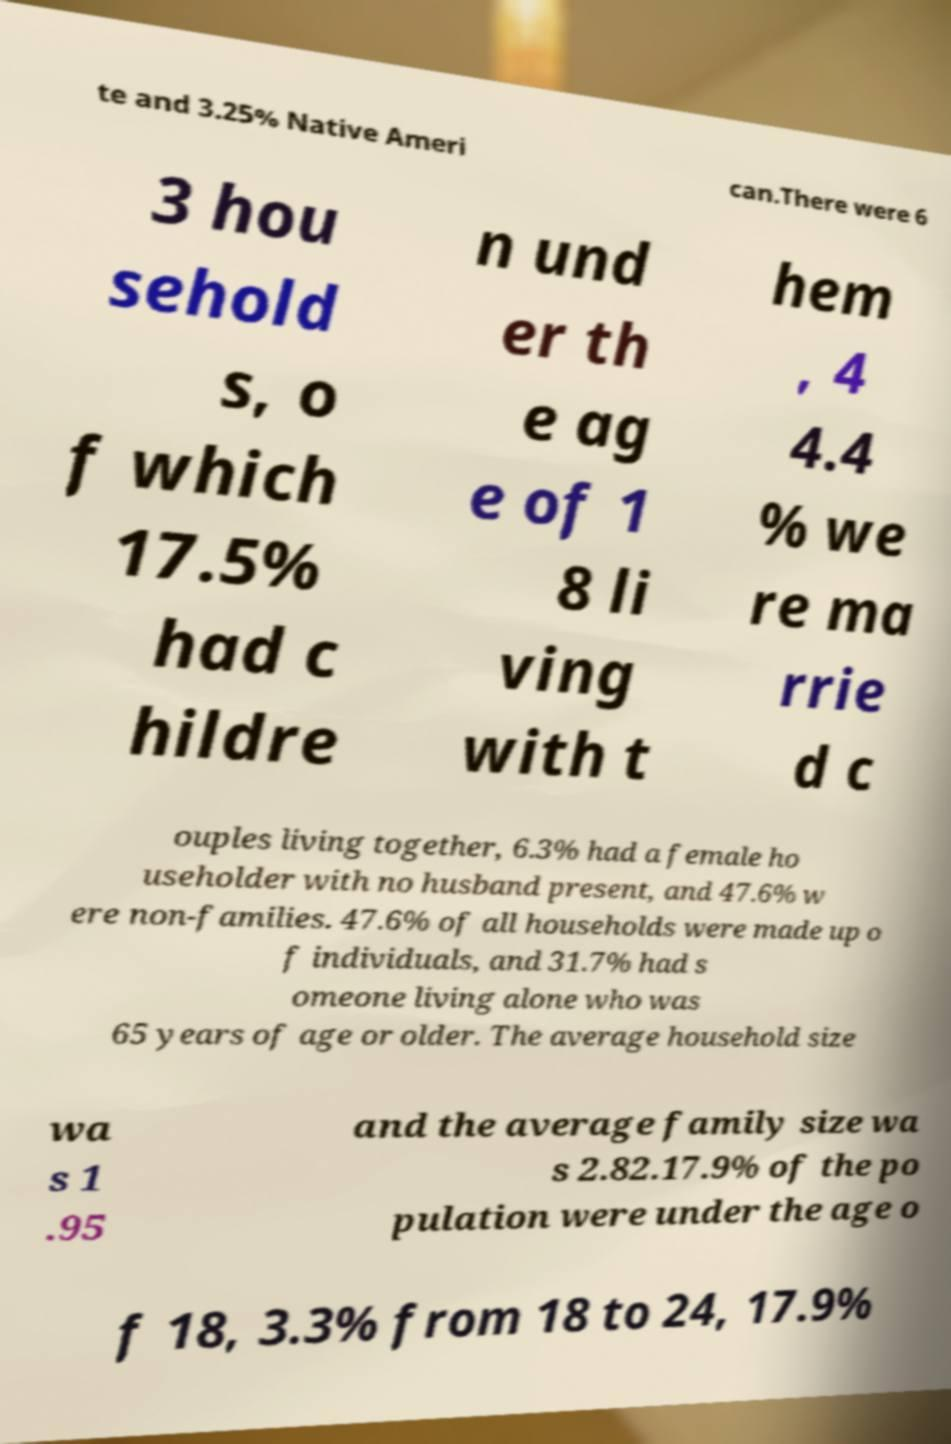Can you read and provide the text displayed in the image?This photo seems to have some interesting text. Can you extract and type it out for me? te and 3.25% Native Ameri can.There were 6 3 hou sehold s, o f which 17.5% had c hildre n und er th e ag e of 1 8 li ving with t hem , 4 4.4 % we re ma rrie d c ouples living together, 6.3% had a female ho useholder with no husband present, and 47.6% w ere non-families. 47.6% of all households were made up o f individuals, and 31.7% had s omeone living alone who was 65 years of age or older. The average household size wa s 1 .95 and the average family size wa s 2.82.17.9% of the po pulation were under the age o f 18, 3.3% from 18 to 24, 17.9% 